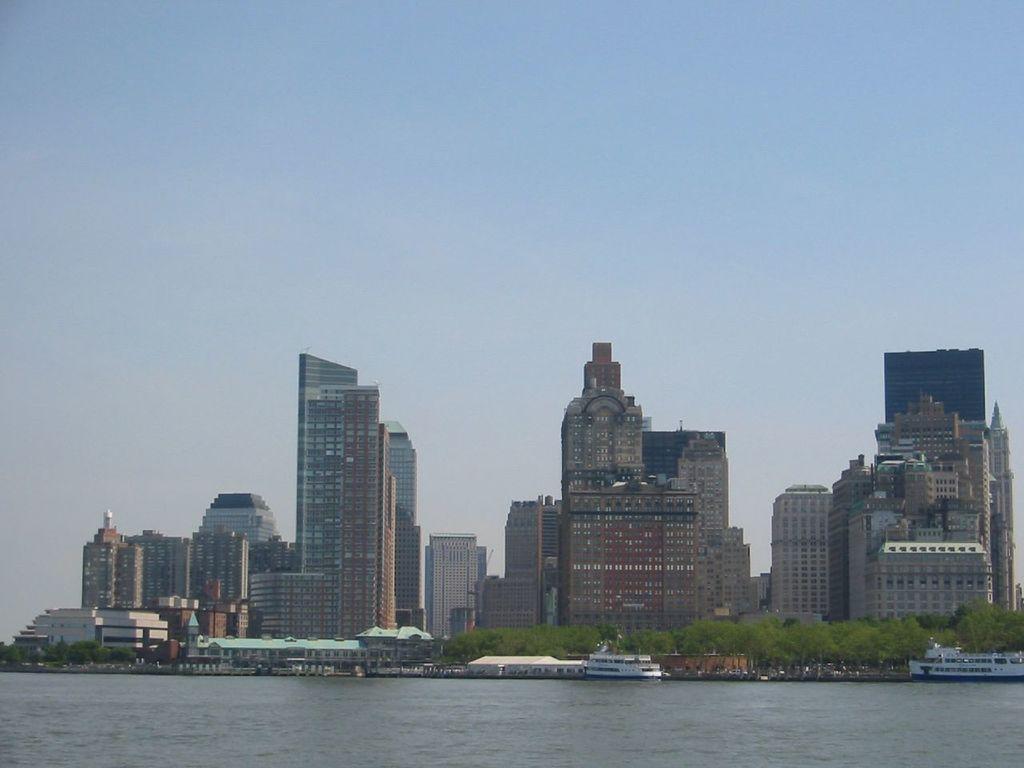Describe this image in one or two sentences. In this image in front there are ships in the water. In the background of the image there are buildings, trees and sky. 